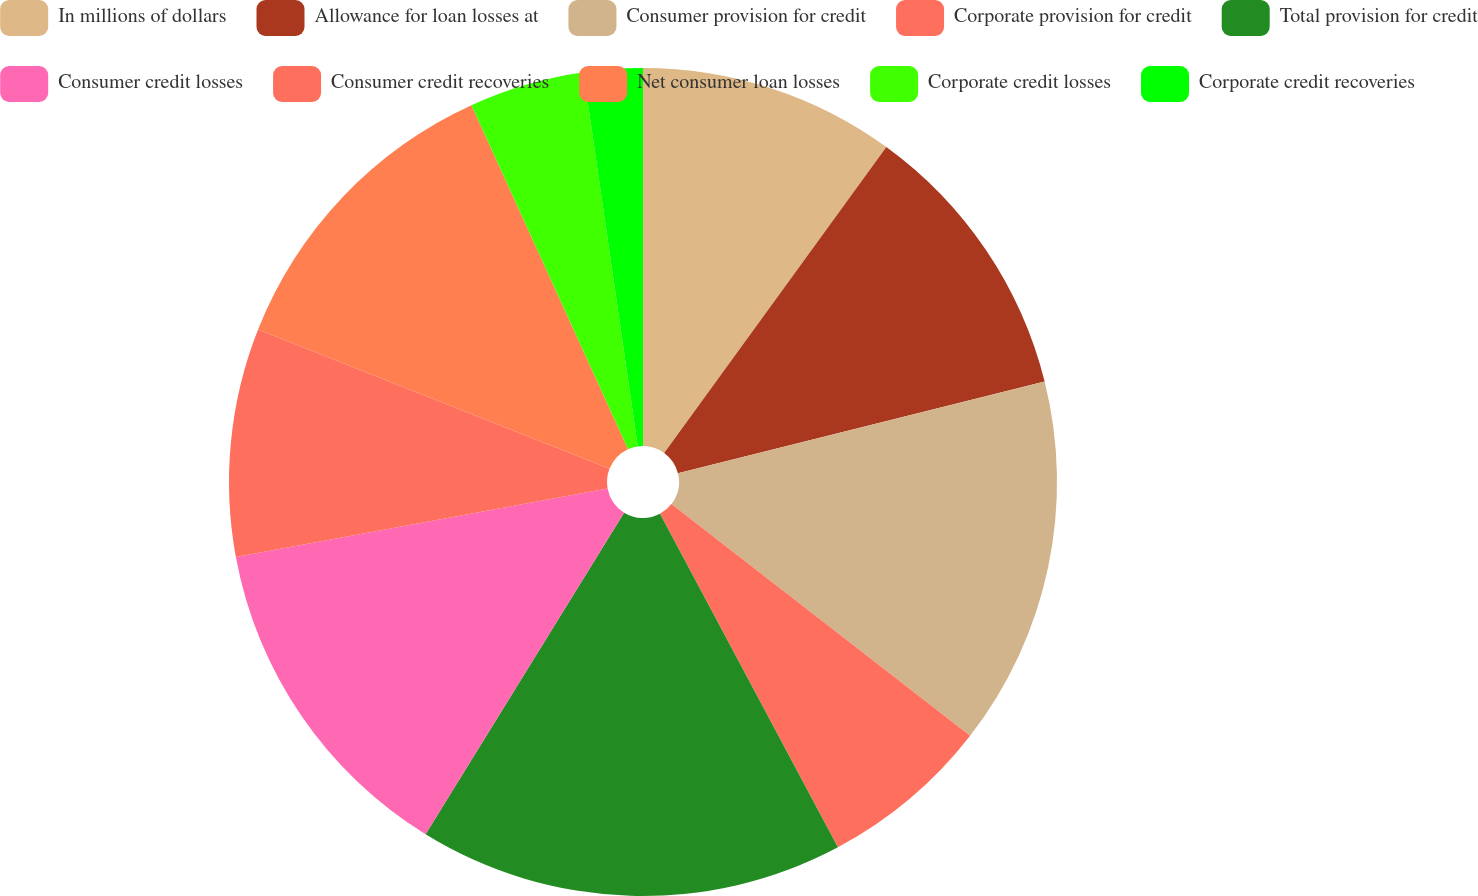<chart> <loc_0><loc_0><loc_500><loc_500><pie_chart><fcel>In millions of dollars<fcel>Allowance for loan losses at<fcel>Consumer provision for credit<fcel>Corporate provision for credit<fcel>Total provision for credit<fcel>Consumer credit losses<fcel>Consumer credit recoveries<fcel>Net consumer loan losses<fcel>Corporate credit losses<fcel>Corporate credit recoveries<nl><fcel>10.0%<fcel>11.1%<fcel>14.4%<fcel>6.7%<fcel>16.6%<fcel>13.3%<fcel>8.9%<fcel>12.2%<fcel>4.5%<fcel>2.3%<nl></chart> 